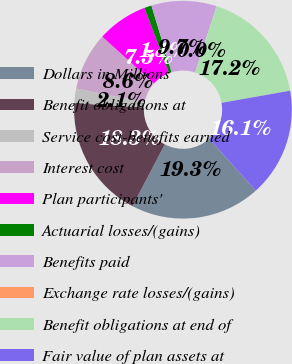Convert chart. <chart><loc_0><loc_0><loc_500><loc_500><pie_chart><fcel>Dollars in Millions<fcel>Benefit obligations at<fcel>Service cost-benefits earned<fcel>Interest cost<fcel>Plan participants'<fcel>Actuarial losses/(gains)<fcel>Benefits paid<fcel>Exchange rate losses/(gains)<fcel>Benefit obligations at end of<fcel>Fair value of plan assets at<nl><fcel>19.35%<fcel>18.28%<fcel>2.15%<fcel>8.6%<fcel>7.53%<fcel>1.08%<fcel>9.68%<fcel>0.01%<fcel>17.2%<fcel>16.13%<nl></chart> 